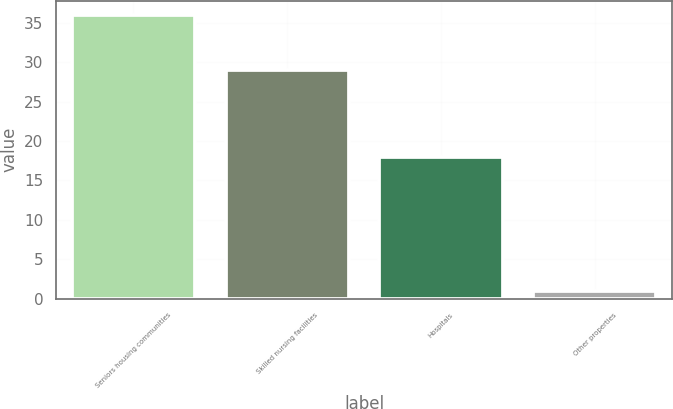<chart> <loc_0><loc_0><loc_500><loc_500><bar_chart><fcel>Seniors housing communities<fcel>Skilled nursing facilities<fcel>Hospitals<fcel>Other properties<nl><fcel>36<fcel>29<fcel>18<fcel>1<nl></chart> 